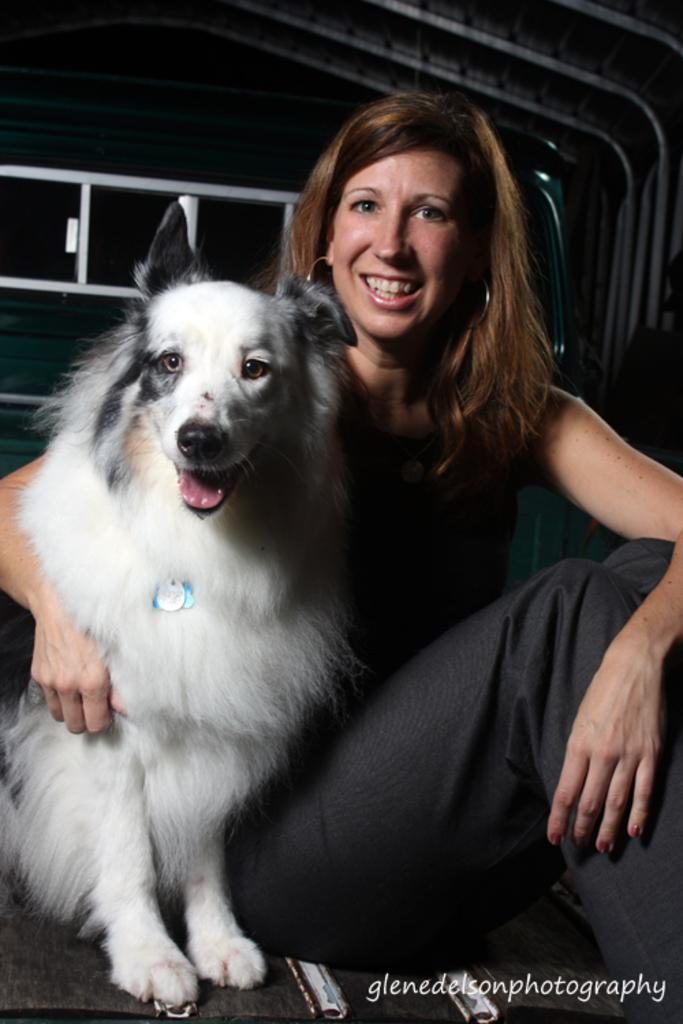Who is present in the image? There is a woman in the image. What is the woman doing in the image? The woman is sitting in the image. Are there any animals present in the image? Yes, there is a dog in the image. How is the woman positioned in relation to the dog? The woman is sitting near the dog in the image. What is the cause of the sleet in the image? There is no mention of sleet in the image; it only features a woman sitting near a dog. How many toes does the dog have in the image? The image does not show the dog's toes, so it cannot be determined from the image. 